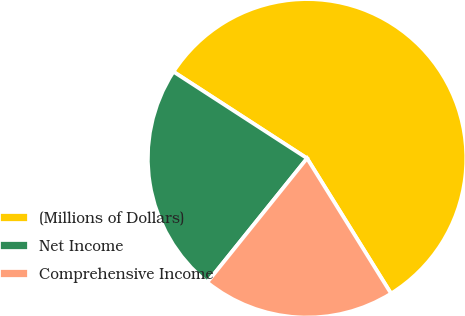<chart> <loc_0><loc_0><loc_500><loc_500><pie_chart><fcel>(Millions of Dollars)<fcel>Net Income<fcel>Comprehensive Income<nl><fcel>57.0%<fcel>23.37%<fcel>19.63%<nl></chart> 